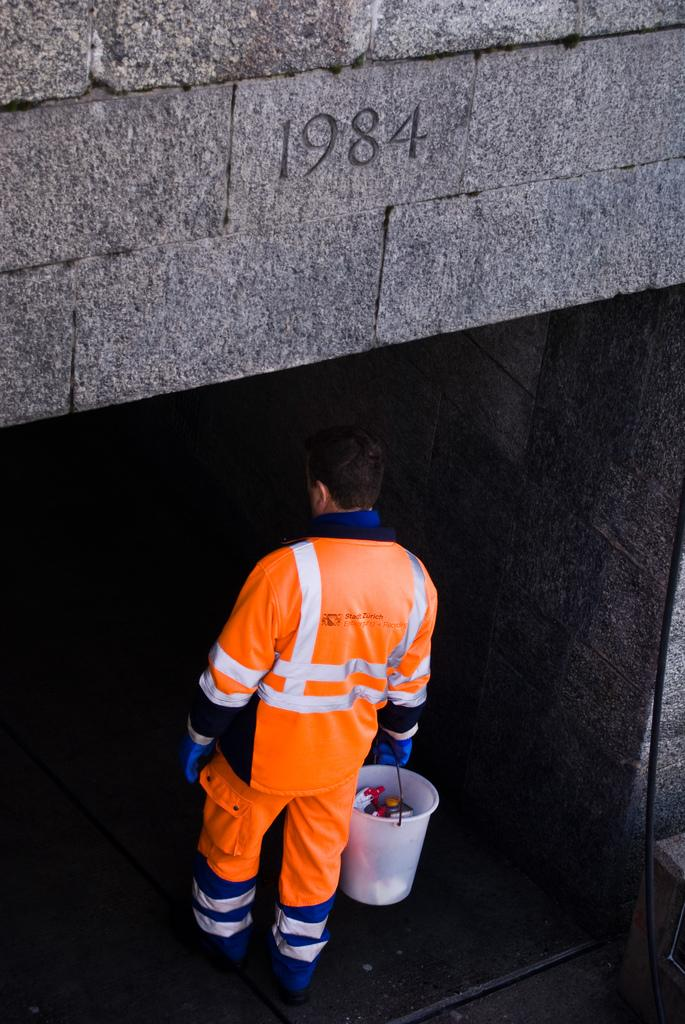<image>
Relay a brief, clear account of the picture shown. Man wearing an orange suit under a number that says 1984. 